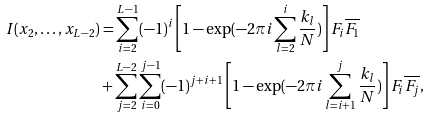<formula> <loc_0><loc_0><loc_500><loc_500>I ( x _ { 2 } , \dots , x _ { L - 2 } ) & = \sum _ { i = 2 } ^ { L - 1 } ( - 1 ) ^ { i } \left [ 1 - \exp ( - 2 \pi i \sum _ { l = 2 } ^ { i } \frac { k _ { l } } { N } ) \right ] F _ { i } \overline { F _ { 1 } } \\ & + \sum _ { j = 2 } ^ { L - 2 } \sum _ { i = 0 } ^ { j - 1 } ( - 1 ) ^ { j + i + 1 } \left [ 1 - \exp ( - 2 \pi i \sum _ { l = i + 1 } ^ { j } \frac { k _ { l } } { N } ) \right ] F _ { i } \overline { F _ { j } } ,</formula> 